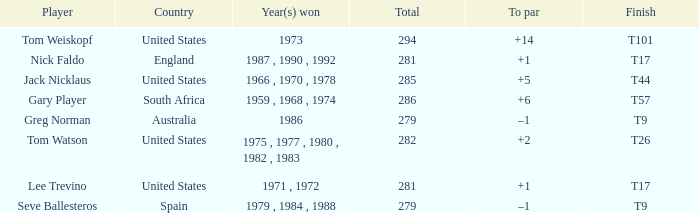Who has the highest total and a to par of +14? 294.0. 